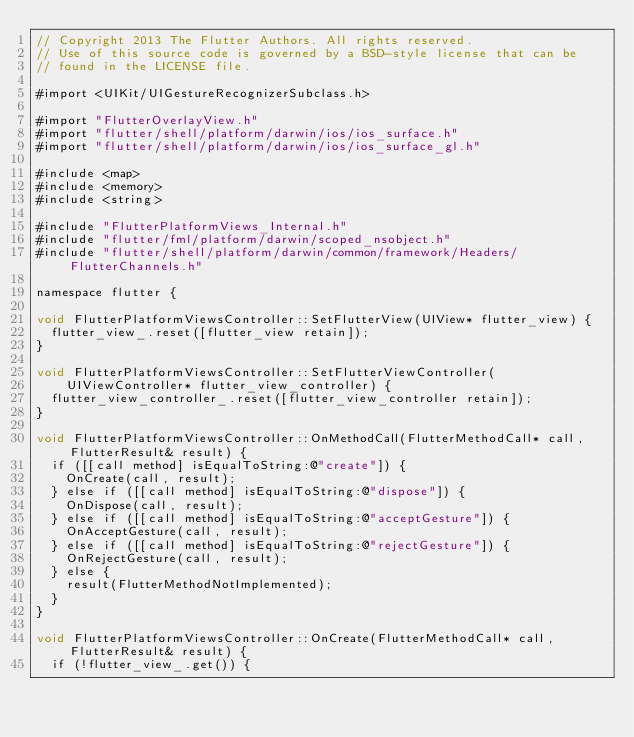<code> <loc_0><loc_0><loc_500><loc_500><_ObjectiveC_>// Copyright 2013 The Flutter Authors. All rights reserved.
// Use of this source code is governed by a BSD-style license that can be
// found in the LICENSE file.

#import <UIKit/UIGestureRecognizerSubclass.h>

#import "FlutterOverlayView.h"
#import "flutter/shell/platform/darwin/ios/ios_surface.h"
#import "flutter/shell/platform/darwin/ios/ios_surface_gl.h"

#include <map>
#include <memory>
#include <string>

#include "FlutterPlatformViews_Internal.h"
#include "flutter/fml/platform/darwin/scoped_nsobject.h"
#include "flutter/shell/platform/darwin/common/framework/Headers/FlutterChannels.h"

namespace flutter {

void FlutterPlatformViewsController::SetFlutterView(UIView* flutter_view) {
  flutter_view_.reset([flutter_view retain]);
}

void FlutterPlatformViewsController::SetFlutterViewController(
    UIViewController* flutter_view_controller) {
  flutter_view_controller_.reset([flutter_view_controller retain]);
}

void FlutterPlatformViewsController::OnMethodCall(FlutterMethodCall* call, FlutterResult& result) {
  if ([[call method] isEqualToString:@"create"]) {
    OnCreate(call, result);
  } else if ([[call method] isEqualToString:@"dispose"]) {
    OnDispose(call, result);
  } else if ([[call method] isEqualToString:@"acceptGesture"]) {
    OnAcceptGesture(call, result);
  } else if ([[call method] isEqualToString:@"rejectGesture"]) {
    OnRejectGesture(call, result);
  } else {
    result(FlutterMethodNotImplemented);
  }
}

void FlutterPlatformViewsController::OnCreate(FlutterMethodCall* call, FlutterResult& result) {
  if (!flutter_view_.get()) {</code> 